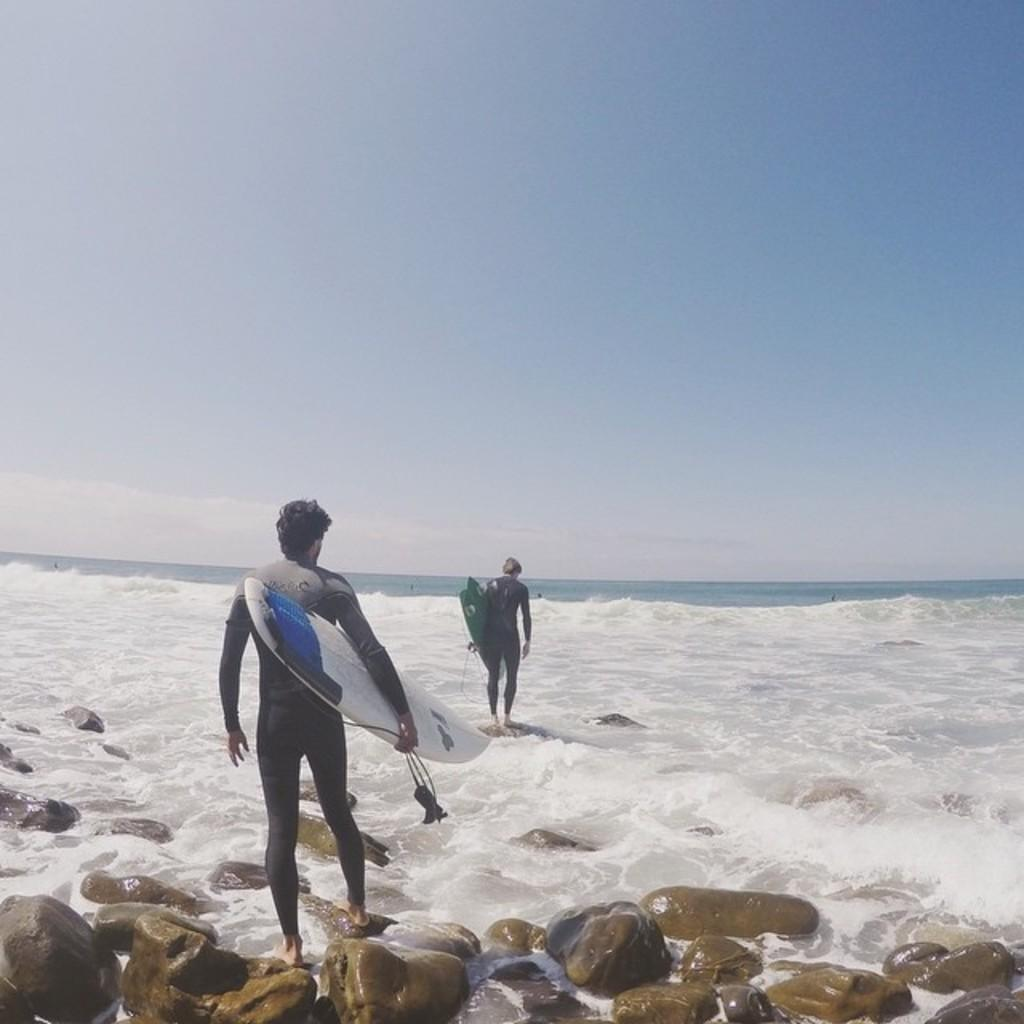How many people are in the image? There are two men in the picture. What are the men doing in the image? The men are walking on the sea and holding a surfing board. What can be seen in the background of the image? There is sky and water visible in the background of the image. What color is the ant's eye in the image? There are no ants or eyes present in the image; it features two men walking on the sea while holding a surfing board. 